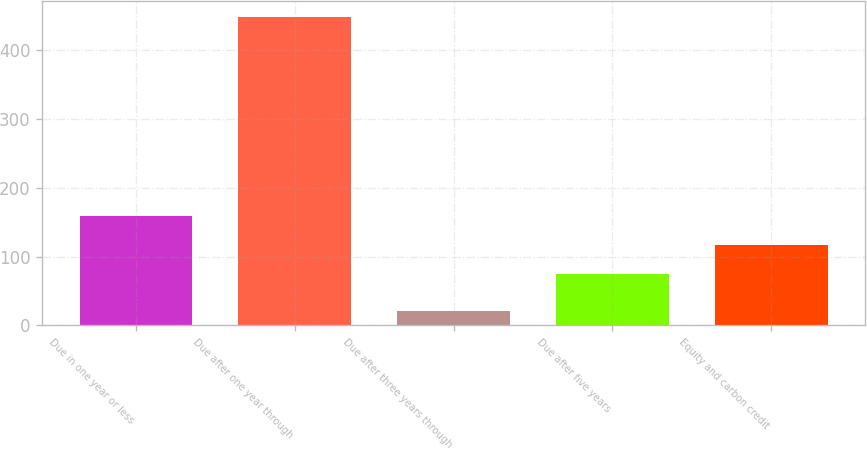<chart> <loc_0><loc_0><loc_500><loc_500><bar_chart><fcel>Due in one year or less<fcel>Due after one year through<fcel>Due after three years through<fcel>Due after five years<fcel>Equity and carbon credit<nl><fcel>159.6<fcel>449<fcel>21<fcel>74<fcel>116.8<nl></chart> 